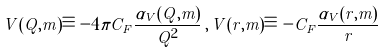<formula> <loc_0><loc_0><loc_500><loc_500>V ( Q , m ) \equiv - 4 \pi C _ { F } \frac { \alpha _ { V } ( Q , m ) } { Q ^ { 2 } } \, , \, V ( r , m ) \equiv - C _ { F } \frac { \alpha _ { V } ( r , m ) } { r }</formula> 